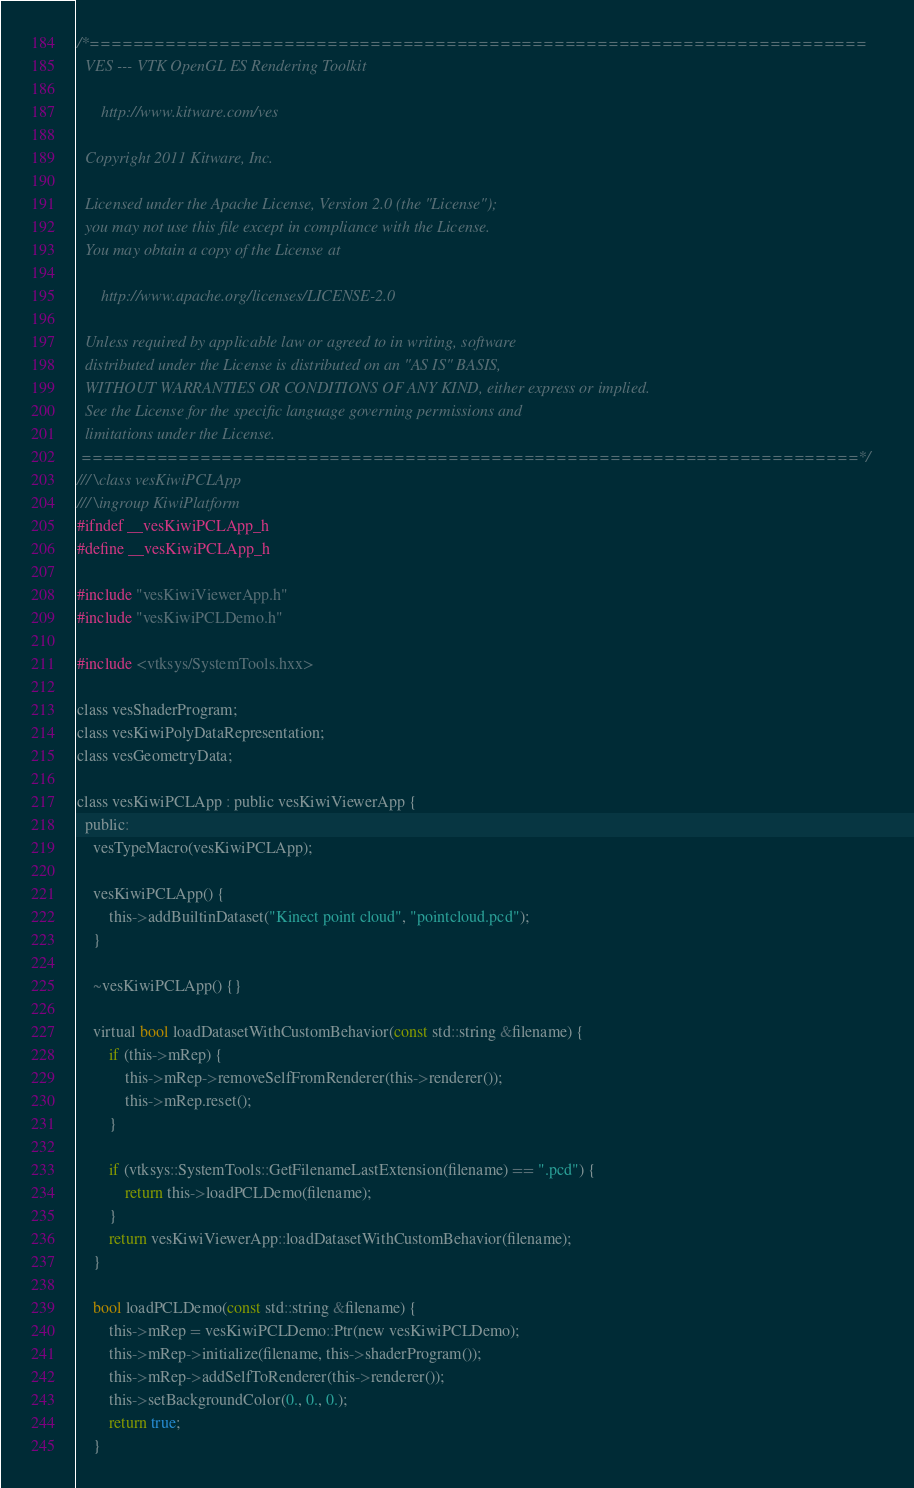Convert code to text. <code><loc_0><loc_0><loc_500><loc_500><_C_>/*========================================================================
  VES --- VTK OpenGL ES Rendering Toolkit

      http://www.kitware.com/ves

  Copyright 2011 Kitware, Inc.

  Licensed under the Apache License, Version 2.0 (the "License");
  you may not use this file except in compliance with the License.
  You may obtain a copy of the License at

      http://www.apache.org/licenses/LICENSE-2.0

  Unless required by applicable law or agreed to in writing, software
  distributed under the License is distributed on an "AS IS" BASIS,
  WITHOUT WARRANTIES OR CONDITIONS OF ANY KIND, either express or implied.
  See the License for the specific language governing permissions and
  limitations under the License.
 ========================================================================*/
/// \class vesKiwiPCLApp
/// \ingroup KiwiPlatform
#ifndef __vesKiwiPCLApp_h
#define __vesKiwiPCLApp_h

#include "vesKiwiViewerApp.h"
#include "vesKiwiPCLDemo.h"

#include <vtksys/SystemTools.hxx>

class vesShaderProgram;
class vesKiwiPolyDataRepresentation;
class vesGeometryData;

class vesKiwiPCLApp : public vesKiwiViewerApp {
  public:
    vesTypeMacro(vesKiwiPCLApp);

    vesKiwiPCLApp() {
        this->addBuiltinDataset("Kinect point cloud", "pointcloud.pcd");
    }

    ~vesKiwiPCLApp() {}

    virtual bool loadDatasetWithCustomBehavior(const std::string &filename) {
        if (this->mRep) {
            this->mRep->removeSelfFromRenderer(this->renderer());
            this->mRep.reset();
        }

        if (vtksys::SystemTools::GetFilenameLastExtension(filename) == ".pcd") {
            return this->loadPCLDemo(filename);
        }
        return vesKiwiViewerApp::loadDatasetWithCustomBehavior(filename);
    }

    bool loadPCLDemo(const std::string &filename) {
        this->mRep = vesKiwiPCLDemo::Ptr(new vesKiwiPCLDemo);
        this->mRep->initialize(filename, this->shaderProgram());
        this->mRep->addSelfToRenderer(this->renderer());
        this->setBackgroundColor(0., 0., 0.);
        return true;
    }
</code> 